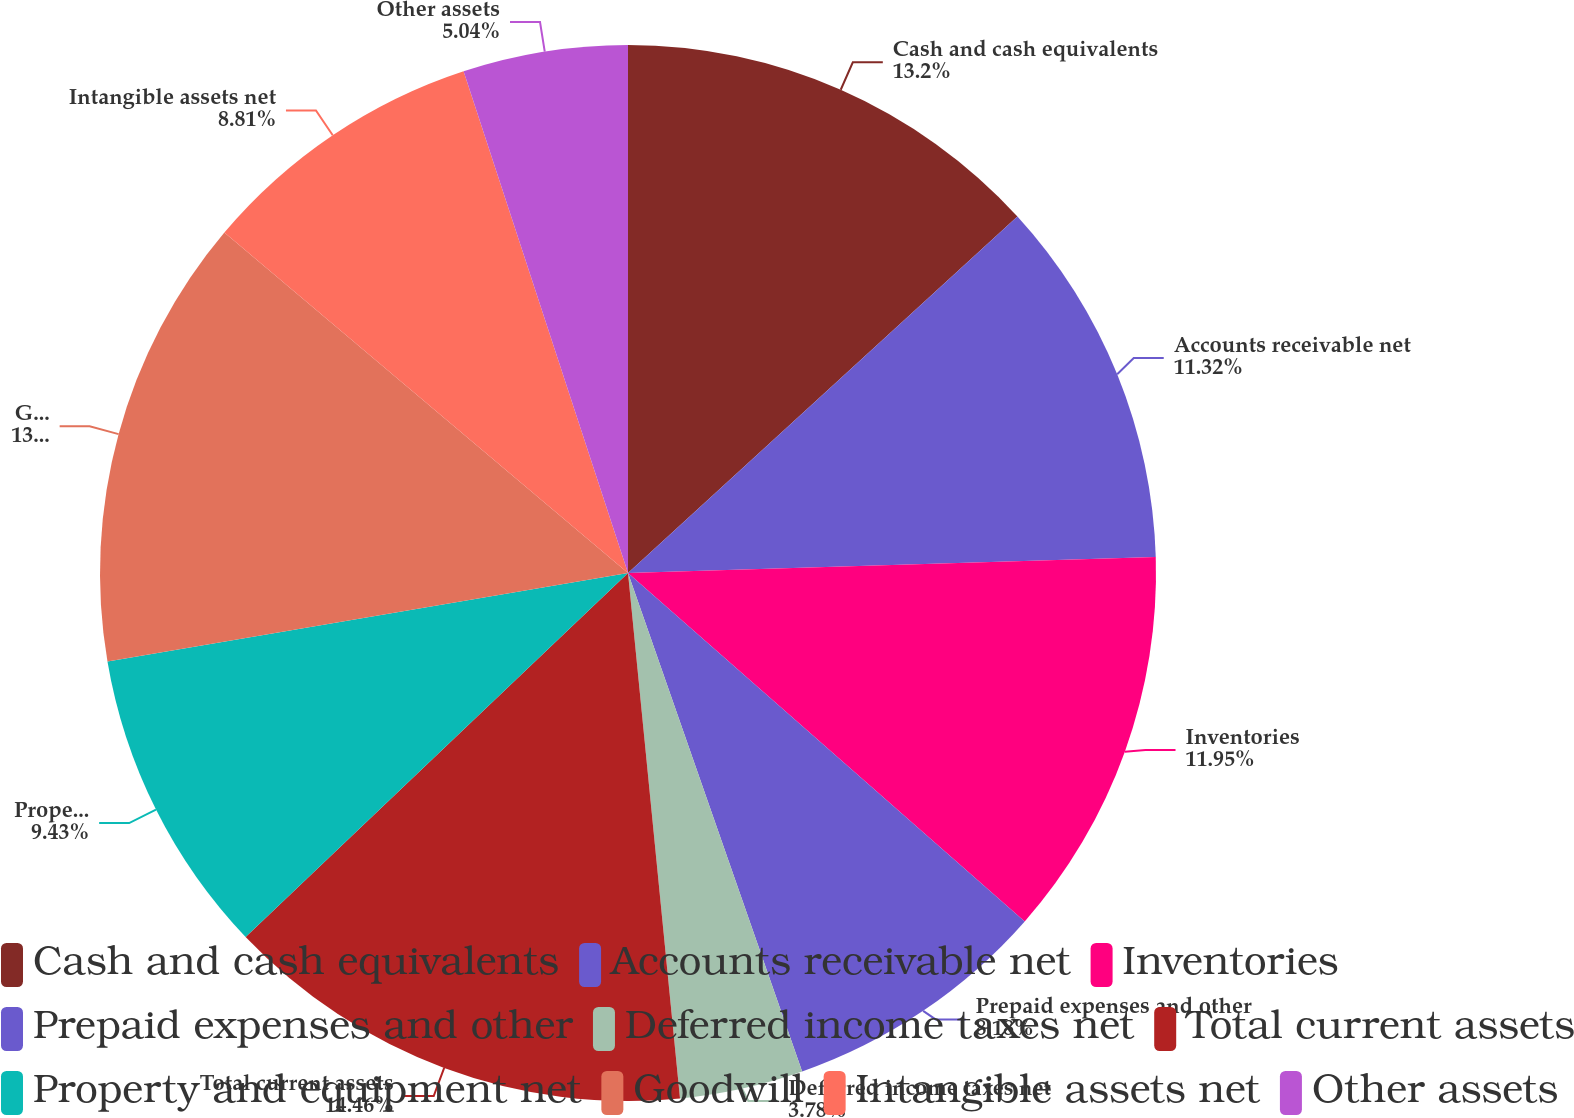<chart> <loc_0><loc_0><loc_500><loc_500><pie_chart><fcel>Cash and cash equivalents<fcel>Accounts receivable net<fcel>Inventories<fcel>Prepaid expenses and other<fcel>Deferred income taxes net<fcel>Total current assets<fcel>Property and equipment net<fcel>Goodwill<fcel>Intangible assets net<fcel>Other assets<nl><fcel>13.2%<fcel>11.32%<fcel>11.95%<fcel>8.18%<fcel>3.78%<fcel>14.46%<fcel>9.43%<fcel>13.83%<fcel>8.81%<fcel>5.04%<nl></chart> 